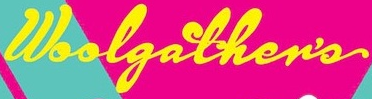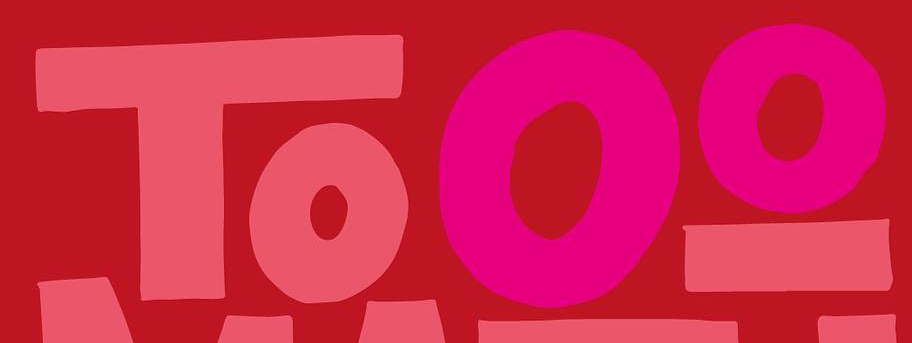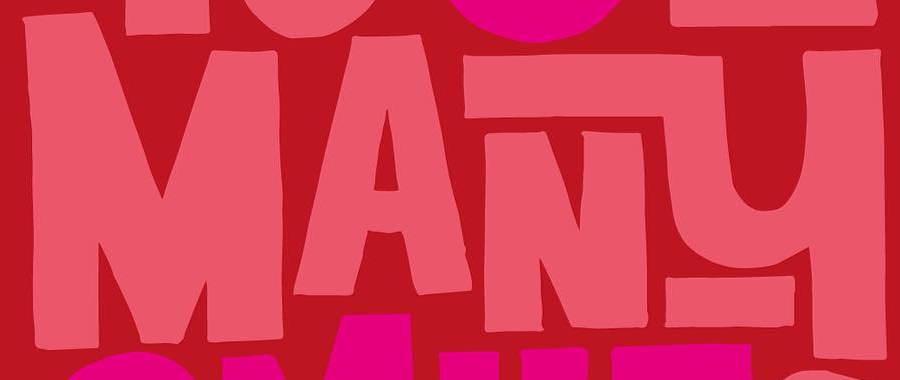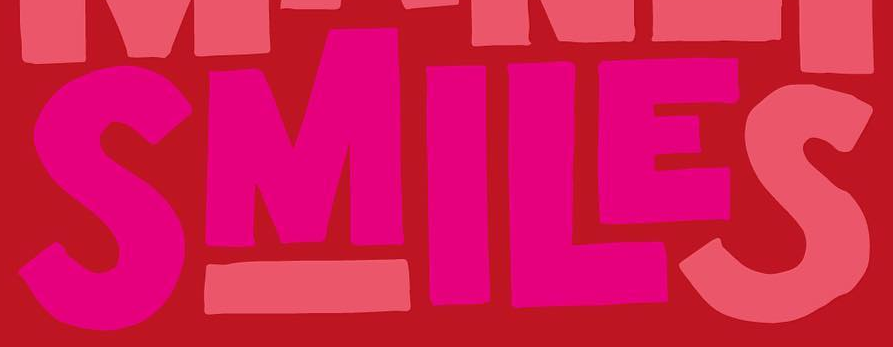What words are shown in these images in order, separated by a semicolon? Woolgather's; Tooo; MANY; SMILES 